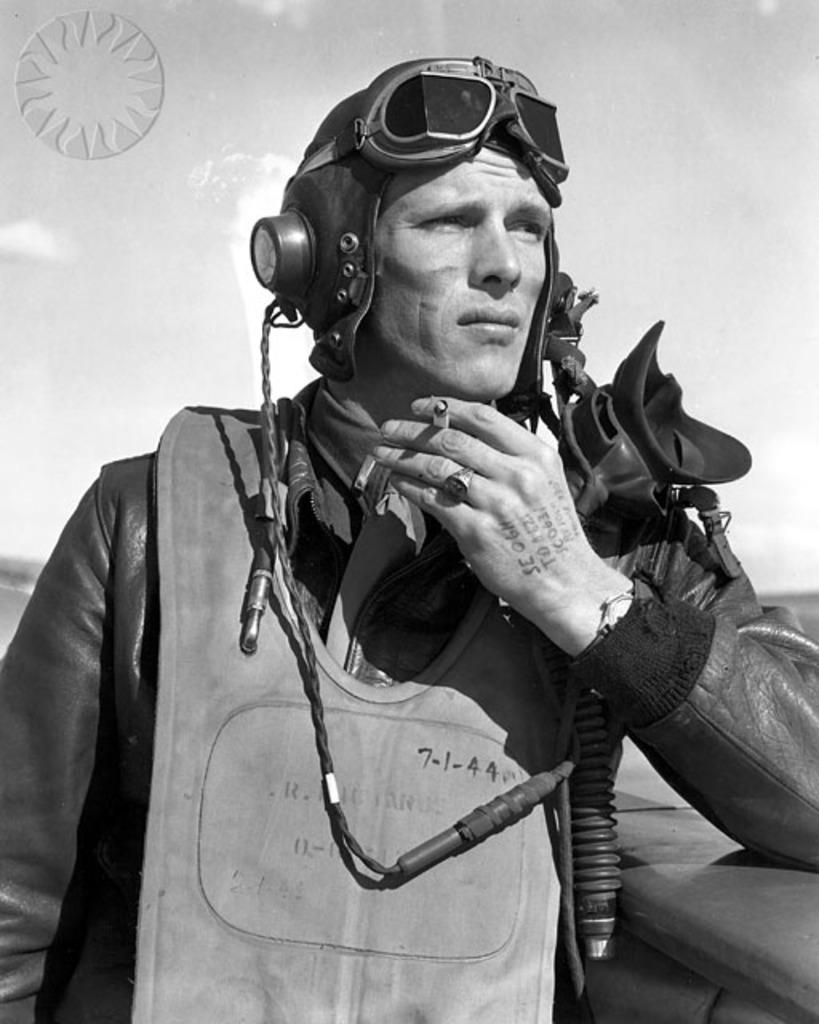Who is the main subject in the image? There is a man standing in the front of the image. What is the man doing in the image? The man is leaning on a wall. Can you describe the background of the image? The background of the image is blurry. What type of destruction can be seen in the image? There is no destruction present in the image; it features a man leaning on a wall with a blurry background. How many trucks are visible in the image? There are no trucks visible in the image. 